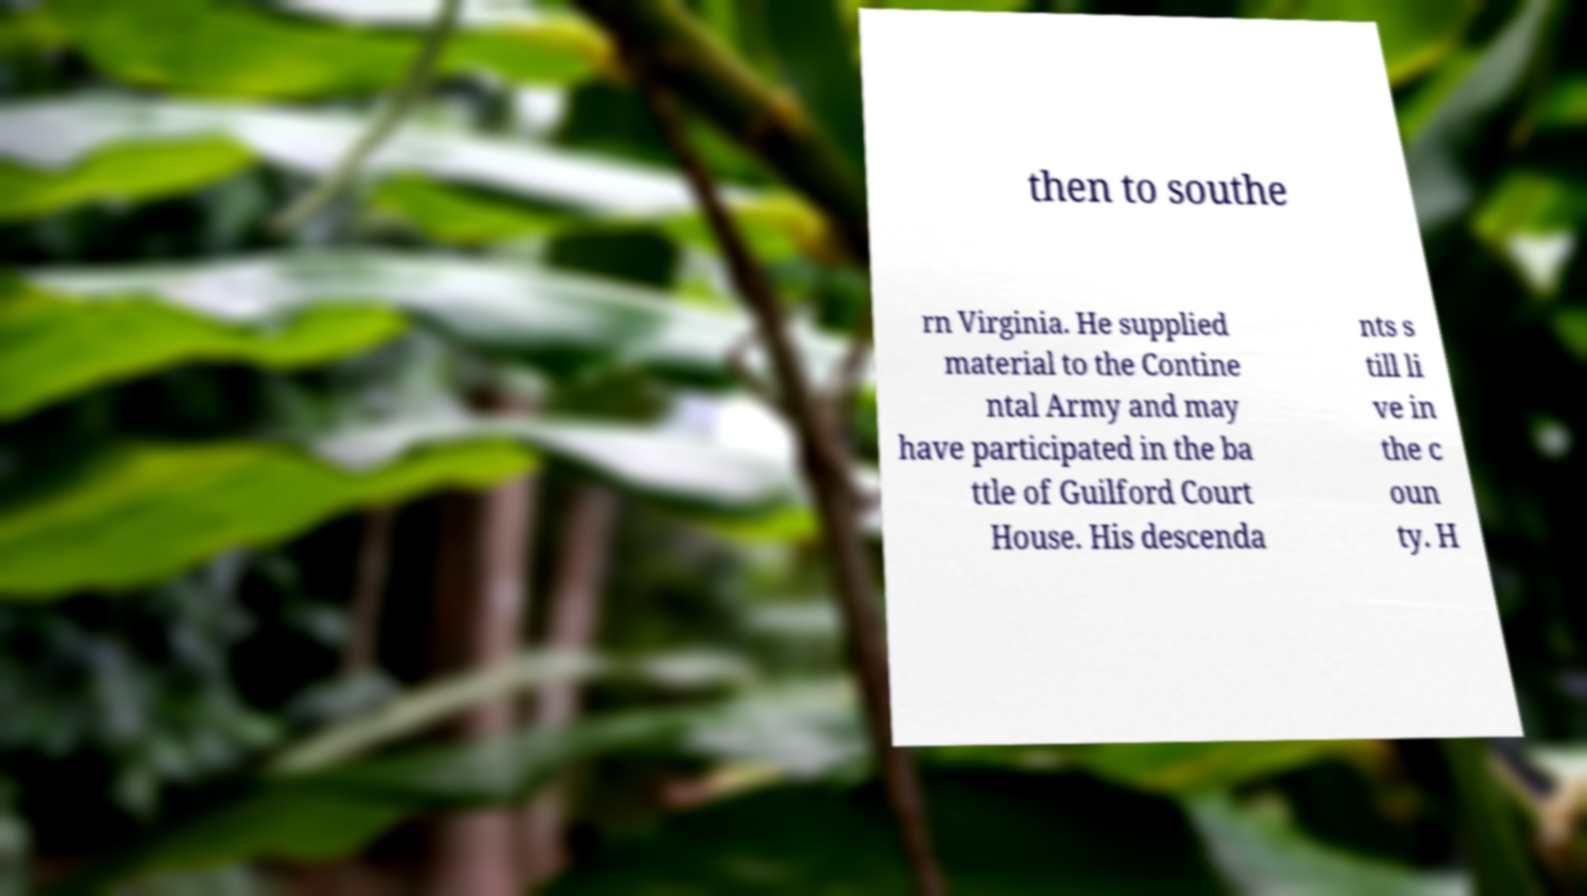Please read and relay the text visible in this image. What does it say? then to southe rn Virginia. He supplied material to the Contine ntal Army and may have participated in the ba ttle of Guilford Court House. His descenda nts s till li ve in the c oun ty. H 